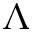Convert formula to latex. <formula><loc_0><loc_0><loc_500><loc_500>\Lambda</formula> 